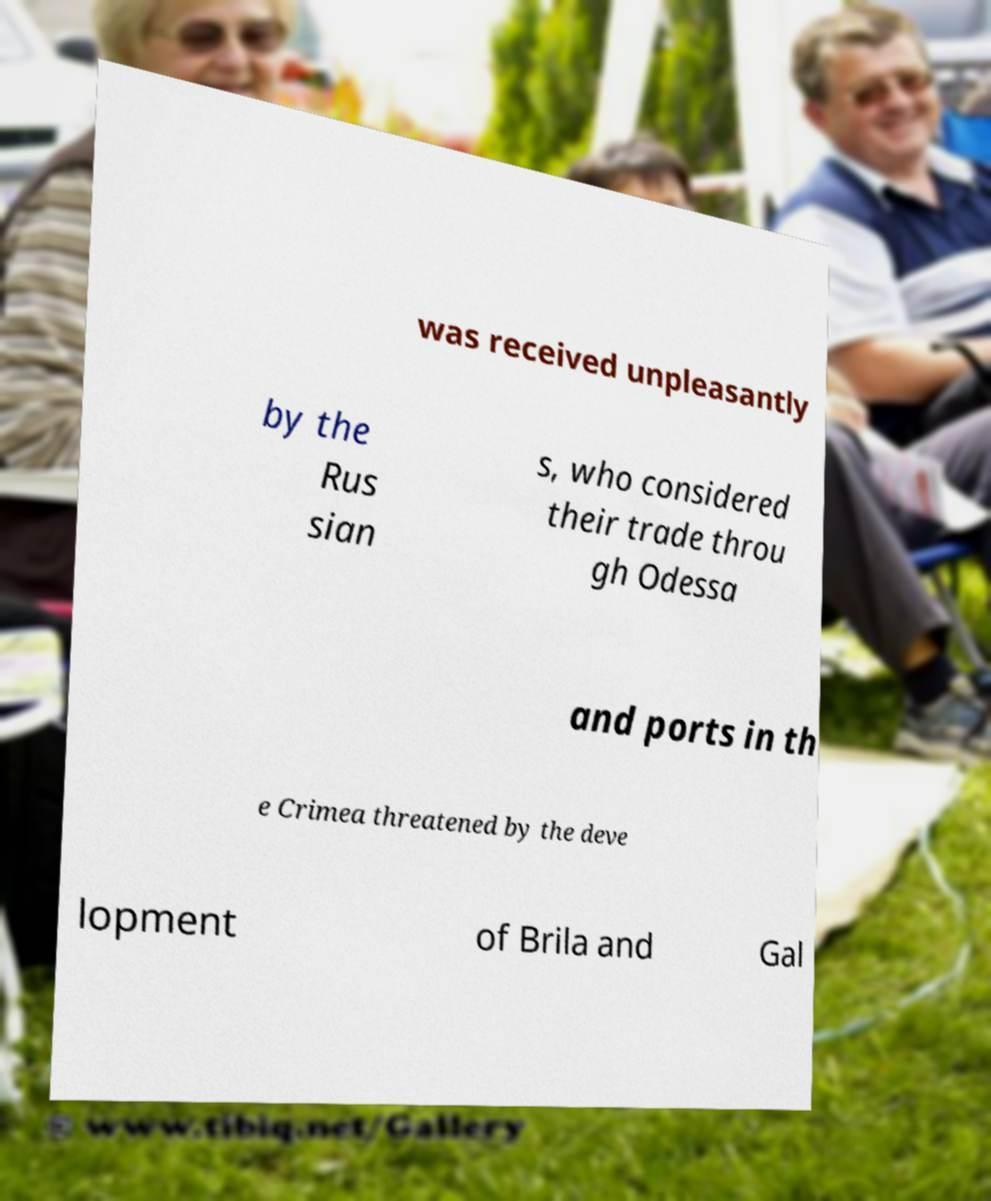I need the written content from this picture converted into text. Can you do that? was received unpleasantly by the Rus sian s, who considered their trade throu gh Odessa and ports in th e Crimea threatened by the deve lopment of Brila and Gal 